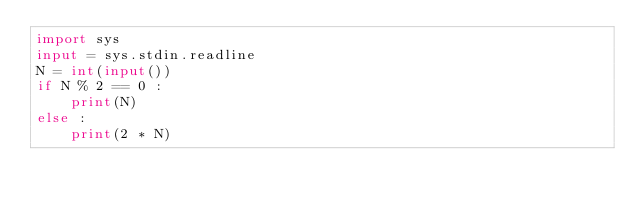<code> <loc_0><loc_0><loc_500><loc_500><_Python_>import sys
input = sys.stdin.readline
N = int(input())
if N % 2 == 0 :
    print(N)
else :
    print(2 * N)</code> 